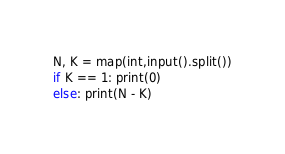Convert code to text. <code><loc_0><loc_0><loc_500><loc_500><_Python_>N, K = map(int,input().split())
if K == 1: print(0)
else: print(N - K)</code> 